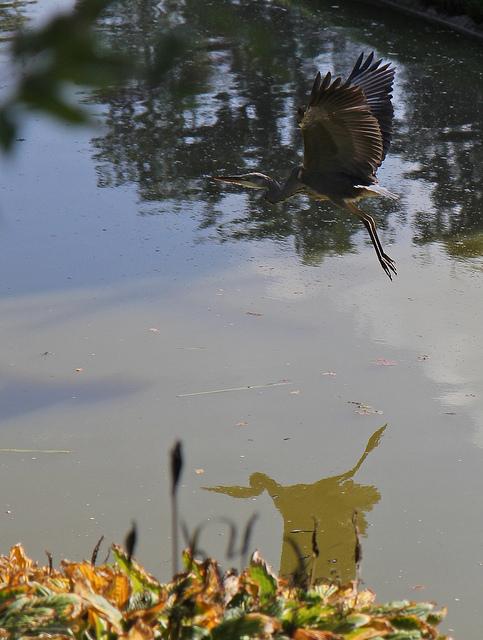Is it daytime?
Quick response, please. Yes. Is the bird in the water?
Write a very short answer. No. Does the bird have webbed feet?
Concise answer only. No. Is there a white bird standing in the river?
Concise answer only. No. Are the birds flying?
Quick response, please. Yes. 